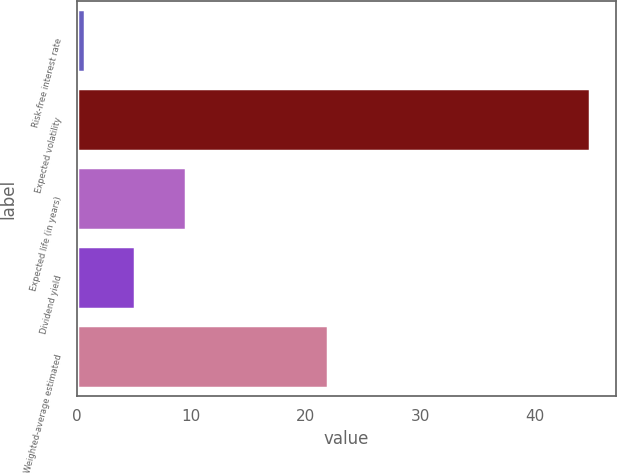Convert chart to OTSL. <chart><loc_0><loc_0><loc_500><loc_500><bar_chart><fcel>Risk-free interest rate<fcel>Expected volatility<fcel>Expected life (in years)<fcel>Dividend yield<fcel>Weighted-average estimated<nl><fcel>0.71<fcel>44.81<fcel>9.53<fcel>5.12<fcel>21.96<nl></chart> 